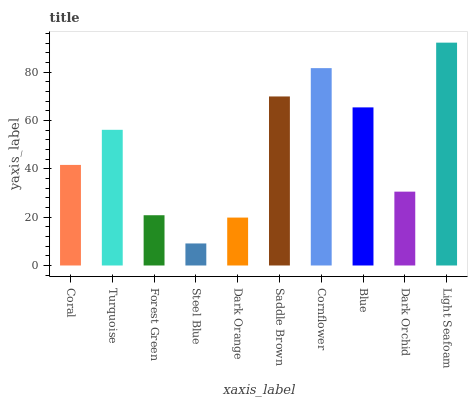Is Steel Blue the minimum?
Answer yes or no. Yes. Is Light Seafoam the maximum?
Answer yes or no. Yes. Is Turquoise the minimum?
Answer yes or no. No. Is Turquoise the maximum?
Answer yes or no. No. Is Turquoise greater than Coral?
Answer yes or no. Yes. Is Coral less than Turquoise?
Answer yes or no. Yes. Is Coral greater than Turquoise?
Answer yes or no. No. Is Turquoise less than Coral?
Answer yes or no. No. Is Turquoise the high median?
Answer yes or no. Yes. Is Coral the low median?
Answer yes or no. Yes. Is Steel Blue the high median?
Answer yes or no. No. Is Saddle Brown the low median?
Answer yes or no. No. 